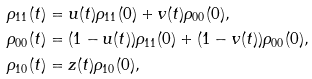<formula> <loc_0><loc_0><loc_500><loc_500>\rho _ { 1 1 } ( t ) & = u ( t ) \rho _ { 1 1 } ( 0 ) + v ( t ) \rho _ { 0 0 } ( 0 ) , \\ \rho _ { 0 0 } ( t ) & = ( 1 - u ( t ) ) \rho _ { 1 1 } ( 0 ) + ( 1 - v ( t ) ) \rho _ { 0 0 } ( 0 ) , \\ \rho _ { 1 0 } ( t ) & = z ( t ) \rho _ { 1 0 } ( 0 ) ,</formula> 